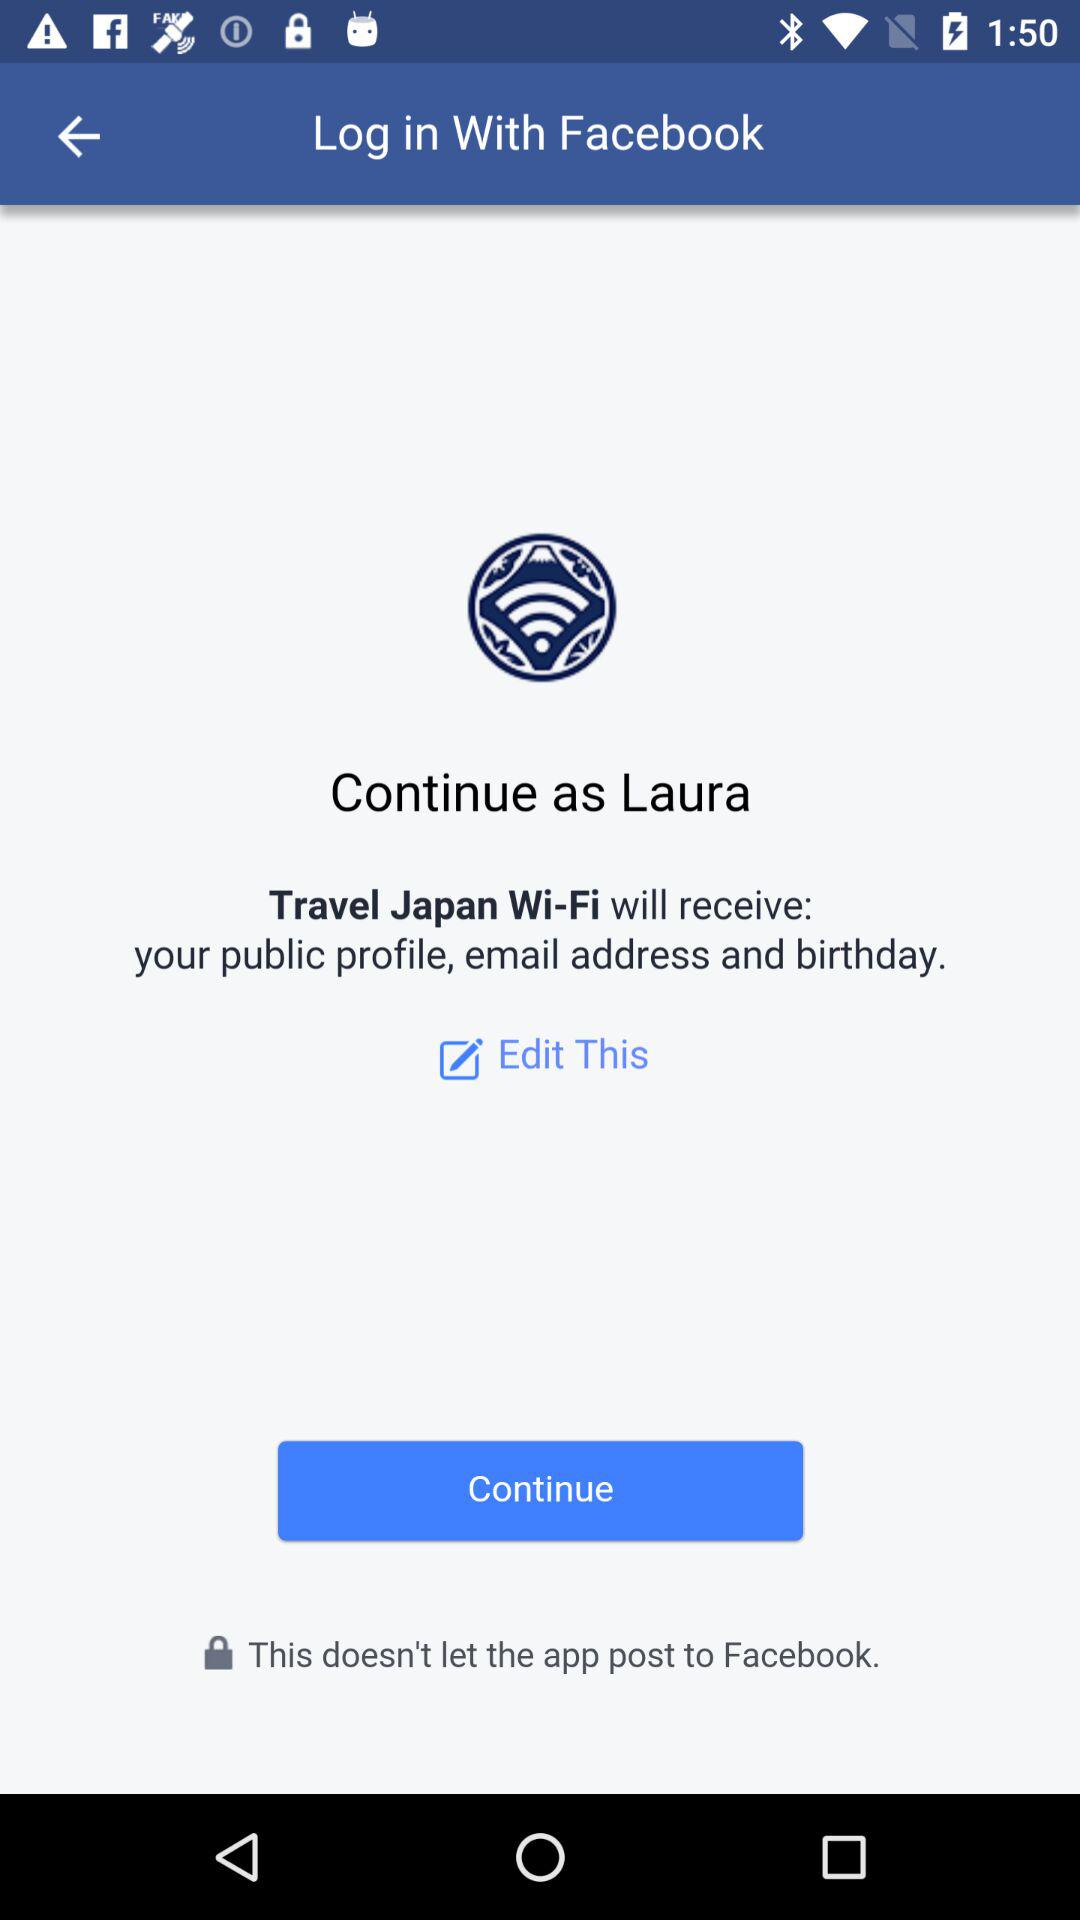What is the login name? The login name is Laura. 